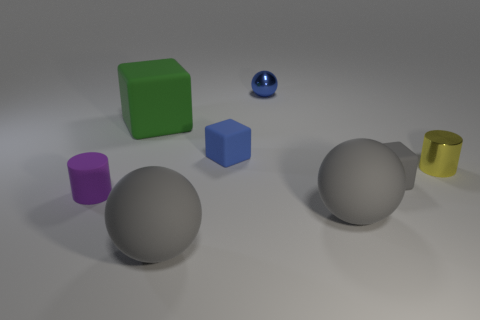Subtract all tiny matte cubes. How many cubes are left? 1 Add 1 green objects. How many objects exist? 9 Subtract all purple cylinders. How many gray spheres are left? 2 Subtract all yellow cylinders. How many cylinders are left? 1 Subtract 1 balls. How many balls are left? 2 Add 3 tiny gray shiny things. How many tiny gray shiny things exist? 3 Subtract 1 blue spheres. How many objects are left? 7 Subtract all cylinders. How many objects are left? 6 Subtract all cyan spheres. Subtract all brown cylinders. How many spheres are left? 3 Subtract all green blocks. Subtract all rubber cylinders. How many objects are left? 6 